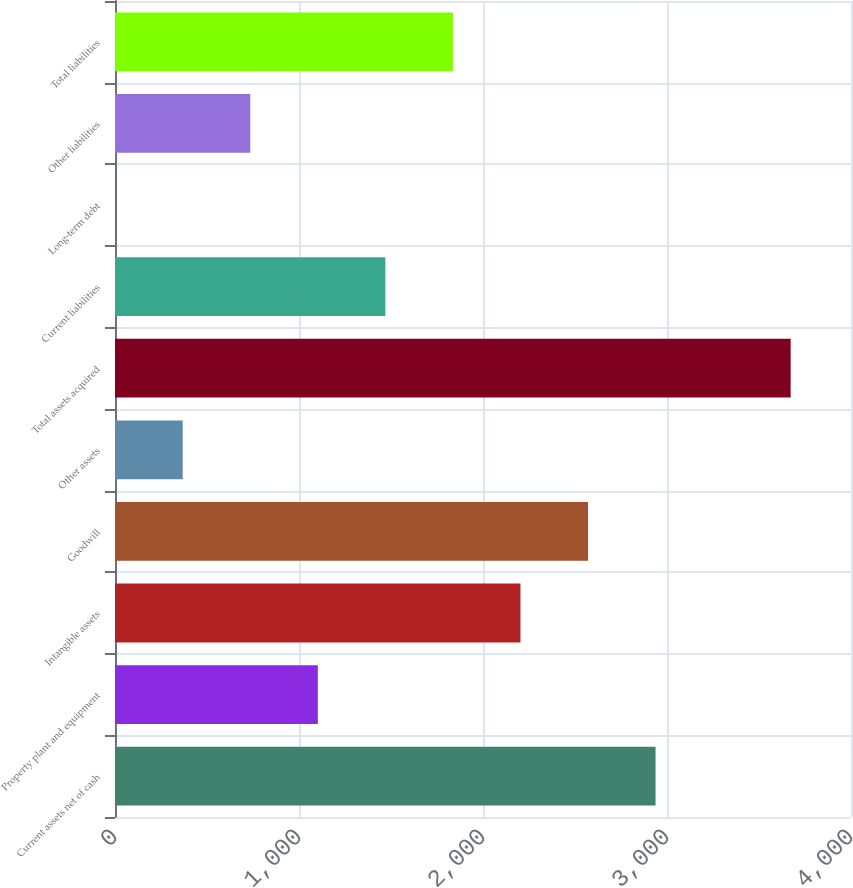Convert chart to OTSL. <chart><loc_0><loc_0><loc_500><loc_500><bar_chart><fcel>Current assets net of cash<fcel>Property plant and equipment<fcel>Intangible assets<fcel>Goodwill<fcel>Other assets<fcel>Total assets acquired<fcel>Current liabilities<fcel>Long-term debt<fcel>Other liabilities<fcel>Total liabilities<nl><fcel>2937.8<fcel>1102.3<fcel>2203.6<fcel>2570.7<fcel>368.1<fcel>3672<fcel>1469.4<fcel>1<fcel>735.2<fcel>1836.5<nl></chart> 